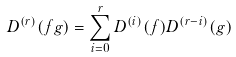<formula> <loc_0><loc_0><loc_500><loc_500>D ^ { ( r ) } ( f g ) = \sum _ { i = 0 } ^ { r } D ^ { ( i ) } ( f ) D ^ { ( r - i ) } ( g )</formula> 